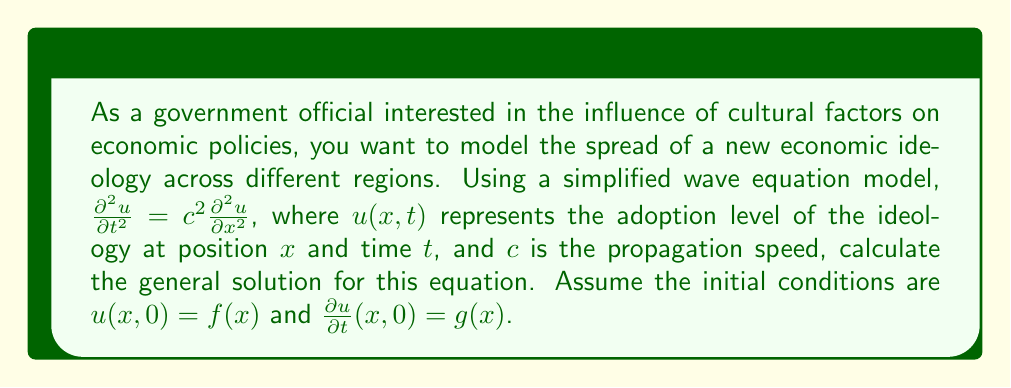Provide a solution to this math problem. To solve this wave equation, we'll follow these steps:

1) The general solution to the 1D wave equation is given by d'Alembert's formula:

   $$u(x,t) = \frac{1}{2}[f(x+ct) + f(x-ct)] + \frac{1}{2c}\int_{x-ct}^{x+ct} g(s) ds$$

2) This solution consists of two parts:
   a) $\frac{1}{2}[f(x+ct) + f(x-ct)]$ represents the propagation of the initial displacement $f(x)$.
   b) $\frac{1}{2c}\int_{x-ct}^{x+ct} g(s) ds$ represents the effect of the initial velocity $g(x)$.

3) The solution shows that the adoption level at any point $(x,t)$ depends on:
   - The initial adoption levels at $x+ct$ and $x-ct$
   - The initial rate of change of adoption levels between $x-ct$ and $x+ct$

4) The constant $c$ determines how quickly the cultural influence spreads. A larger $c$ means faster propagation.

5) This model assumes that the cultural influence spreads symmetrically in both directions and at a constant speed, which may be an oversimplification for real-world scenarios.

6) For specific initial conditions $f(x)$ and $g(x)$, we could substitute them into this general solution to get a more concrete result.
Answer: $$u(x,t) = \frac{1}{2}[f(x+ct) + f(x-ct)] + \frac{1}{2c}\int_{x-ct}^{x+ct} g(s) ds$$ 